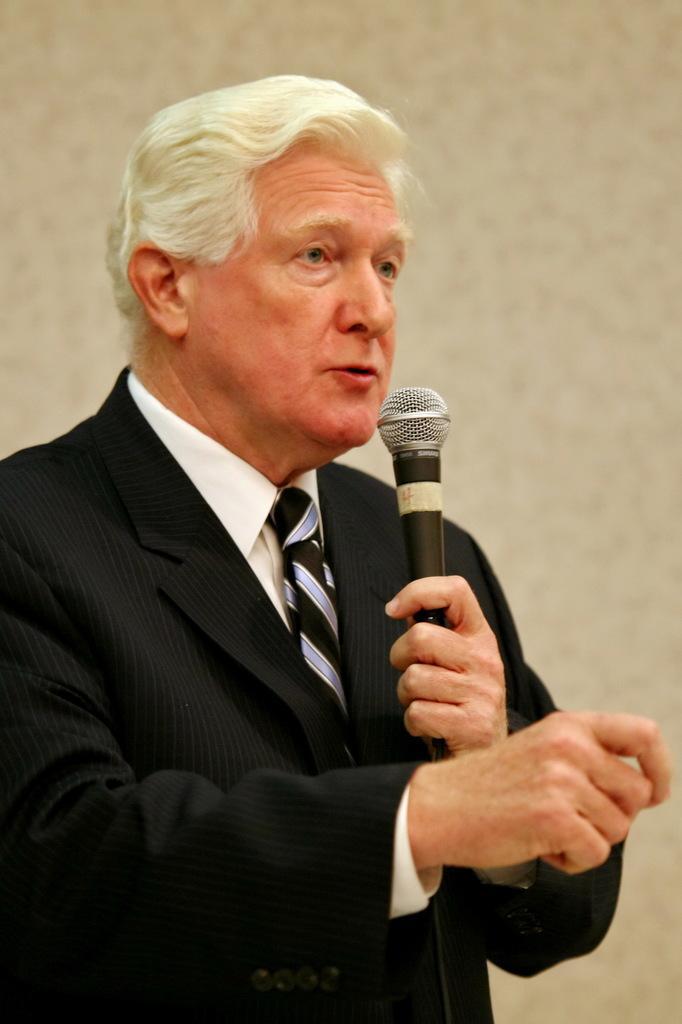Can you describe this image briefly? In this picture, man in white shirt and black blazer is holding microphone in his hand and he is talking on it. He is an old man. 